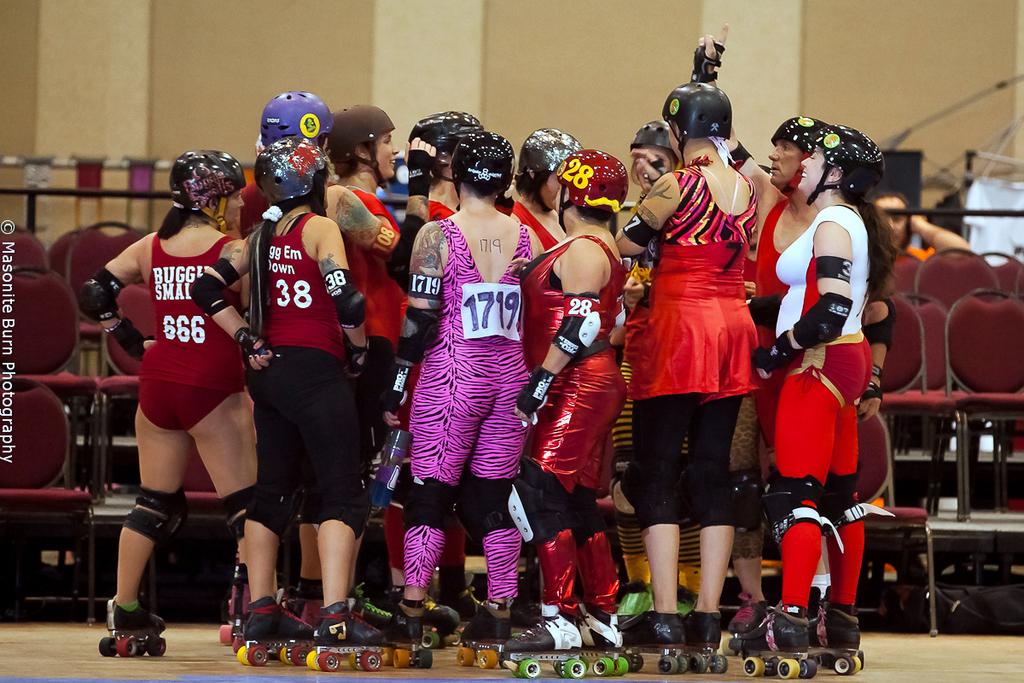What is the roller derby girls number in the pink zebra?
Your answer should be very brief. 1719. What is the number of the player next to the player in pink?
Offer a terse response. 28. 